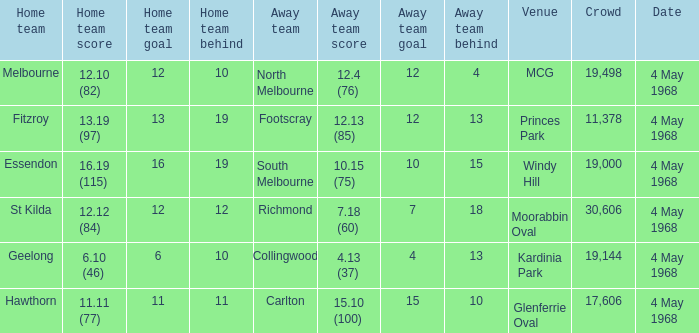What home team played at MCG? North Melbourne. Could you parse the entire table? {'header': ['Home team', 'Home team score', 'Home team goal', 'Home team behind', 'Away team', 'Away team score', 'Away team goal', 'Away team behind', 'Venue', 'Crowd', 'Date'], 'rows': [['Melbourne', '12.10 (82)', '12', '10', 'North Melbourne', '12.4 (76)', '12', '4', 'MCG', '19,498', '4 May 1968'], ['Fitzroy', '13.19 (97)', '13', '19', 'Footscray', '12.13 (85)', '12', '13', 'Princes Park', '11,378', '4 May 1968'], ['Essendon', '16.19 (115)', '16', '19', 'South Melbourne', '10.15 (75)', '10', '15', 'Windy Hill', '19,000', '4 May 1968'], ['St Kilda', '12.12 (84)', '12', '12', 'Richmond', '7.18 (60)', '7', '18', 'Moorabbin Oval', '30,606', '4 May 1968'], ['Geelong', '6.10 (46)', '6', '10', 'Collingwood', '4.13 (37)', '4', '13', 'Kardinia Park', '19,144', '4 May 1968'], ['Hawthorn', '11.11 (77)', '11', '11', 'Carlton', '15.10 (100)', '15', '10', 'Glenferrie Oval', '17,606', '4 May 1968']]} 